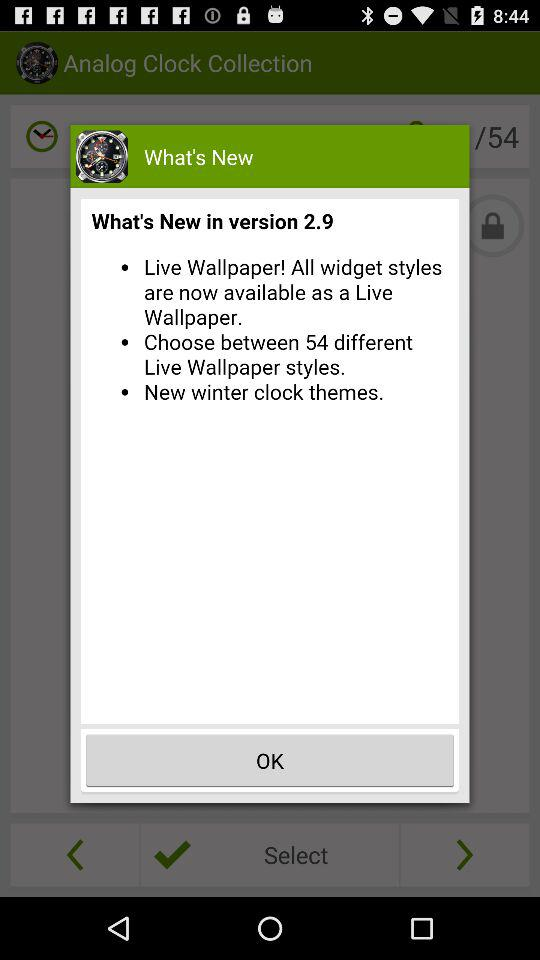What's the number of different Live Wallpaper styles? The number of different Live Wallpaper styles is 54. 